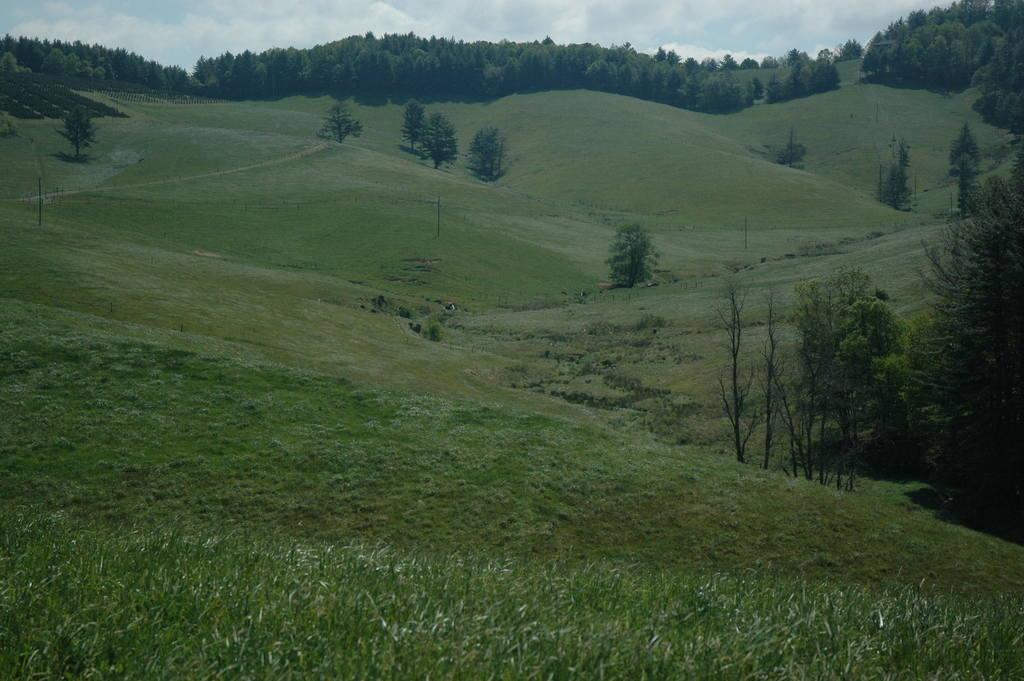Please provide a concise description of this image. In this picture we can see the hills, trees. In the background of the image we can see the grass. At the top of the image we can see the clouds are present in the sky. 